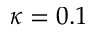Convert formula to latex. <formula><loc_0><loc_0><loc_500><loc_500>\kappa = 0 . 1</formula> 